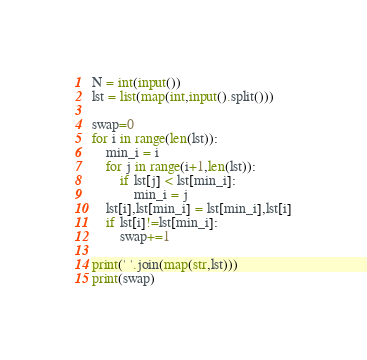Convert code to text. <code><loc_0><loc_0><loc_500><loc_500><_Python_>N = int(input())
lst = list(map(int,input().split()))

swap=0
for i in range(len(lst)):
    min_i = i
    for j in range(i+1,len(lst)):
        if lst[j] < lst[min_i]:
            min_i = j
    lst[i],lst[min_i] = lst[min_i],lst[i]
    if lst[i]!=lst[min_i]:
        swap+=1

print(' '.join(map(str,lst)))
print(swap)
</code> 